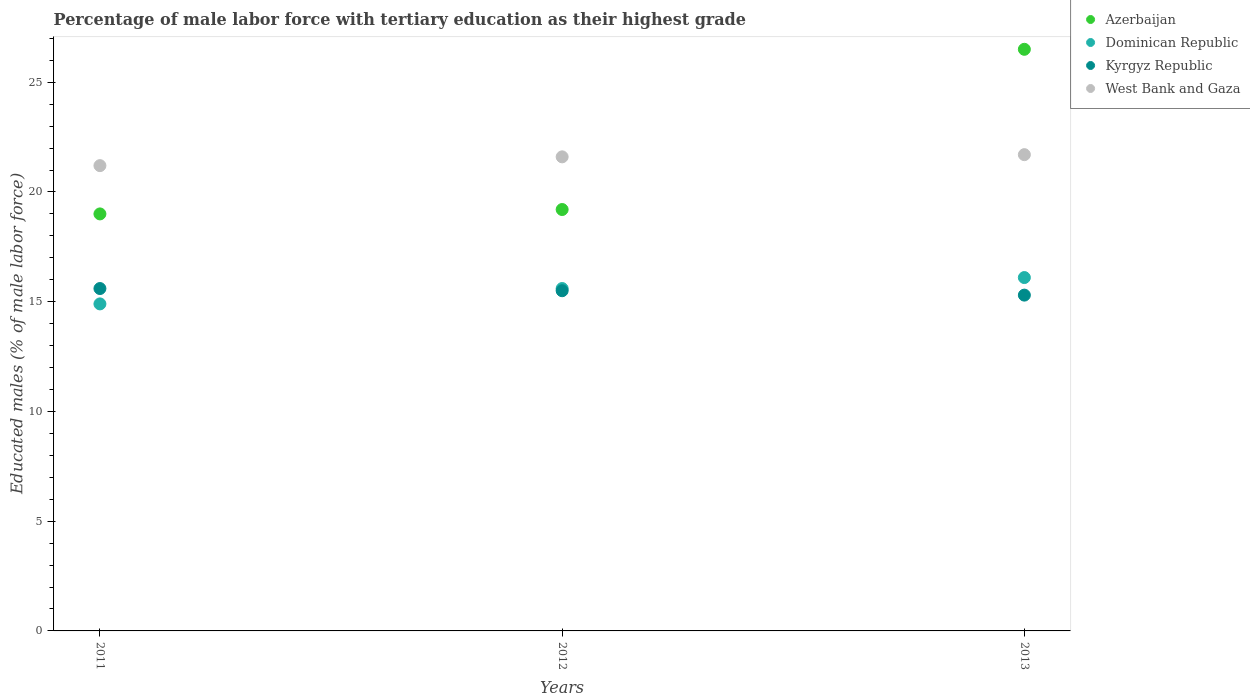What is the percentage of male labor force with tertiary education in West Bank and Gaza in 2011?
Offer a terse response. 21.2. Across all years, what is the maximum percentage of male labor force with tertiary education in Dominican Republic?
Ensure brevity in your answer.  16.1. Across all years, what is the minimum percentage of male labor force with tertiary education in Dominican Republic?
Give a very brief answer. 14.9. What is the total percentage of male labor force with tertiary education in Azerbaijan in the graph?
Keep it short and to the point. 64.7. What is the difference between the percentage of male labor force with tertiary education in Azerbaijan in 2012 and that in 2013?
Keep it short and to the point. -7.3. What is the difference between the percentage of male labor force with tertiary education in West Bank and Gaza in 2011 and the percentage of male labor force with tertiary education in Kyrgyz Republic in 2012?
Offer a terse response. 5.7. What is the average percentage of male labor force with tertiary education in Azerbaijan per year?
Give a very brief answer. 21.57. In the year 2011, what is the difference between the percentage of male labor force with tertiary education in Dominican Republic and percentage of male labor force with tertiary education in Kyrgyz Republic?
Provide a succinct answer. -0.7. In how many years, is the percentage of male labor force with tertiary education in Kyrgyz Republic greater than 2 %?
Your answer should be very brief. 3. What is the ratio of the percentage of male labor force with tertiary education in Dominican Republic in 2011 to that in 2013?
Ensure brevity in your answer.  0.93. What is the difference between the highest and the second highest percentage of male labor force with tertiary education in West Bank and Gaza?
Give a very brief answer. 0.1. What is the difference between the highest and the lowest percentage of male labor force with tertiary education in Kyrgyz Republic?
Keep it short and to the point. 0.3. In how many years, is the percentage of male labor force with tertiary education in Dominican Republic greater than the average percentage of male labor force with tertiary education in Dominican Republic taken over all years?
Keep it short and to the point. 2. Is the sum of the percentage of male labor force with tertiary education in Dominican Republic in 2011 and 2012 greater than the maximum percentage of male labor force with tertiary education in West Bank and Gaza across all years?
Give a very brief answer. Yes. Is it the case that in every year, the sum of the percentage of male labor force with tertiary education in Azerbaijan and percentage of male labor force with tertiary education in West Bank and Gaza  is greater than the sum of percentage of male labor force with tertiary education in Dominican Republic and percentage of male labor force with tertiary education in Kyrgyz Republic?
Provide a short and direct response. Yes. Does the percentage of male labor force with tertiary education in Dominican Republic monotonically increase over the years?
Provide a succinct answer. Yes. Is the percentage of male labor force with tertiary education in Dominican Republic strictly greater than the percentage of male labor force with tertiary education in Azerbaijan over the years?
Offer a terse response. No. Is the percentage of male labor force with tertiary education in Kyrgyz Republic strictly less than the percentage of male labor force with tertiary education in Dominican Republic over the years?
Provide a succinct answer. No. How many dotlines are there?
Give a very brief answer. 4. How many years are there in the graph?
Your response must be concise. 3. Does the graph contain any zero values?
Ensure brevity in your answer.  No. Does the graph contain grids?
Keep it short and to the point. No. Where does the legend appear in the graph?
Your answer should be compact. Top right. How many legend labels are there?
Give a very brief answer. 4. What is the title of the graph?
Your answer should be very brief. Percentage of male labor force with tertiary education as their highest grade. Does "Solomon Islands" appear as one of the legend labels in the graph?
Offer a terse response. No. What is the label or title of the Y-axis?
Your answer should be compact. Educated males (% of male labor force). What is the Educated males (% of male labor force) in Dominican Republic in 2011?
Your answer should be very brief. 14.9. What is the Educated males (% of male labor force) in Kyrgyz Republic in 2011?
Offer a very short reply. 15.6. What is the Educated males (% of male labor force) of West Bank and Gaza in 2011?
Give a very brief answer. 21.2. What is the Educated males (% of male labor force) in Azerbaijan in 2012?
Your answer should be very brief. 19.2. What is the Educated males (% of male labor force) of Dominican Republic in 2012?
Ensure brevity in your answer.  15.6. What is the Educated males (% of male labor force) of Kyrgyz Republic in 2012?
Ensure brevity in your answer.  15.5. What is the Educated males (% of male labor force) in West Bank and Gaza in 2012?
Keep it short and to the point. 21.6. What is the Educated males (% of male labor force) of Azerbaijan in 2013?
Keep it short and to the point. 26.5. What is the Educated males (% of male labor force) in Dominican Republic in 2013?
Offer a very short reply. 16.1. What is the Educated males (% of male labor force) in Kyrgyz Republic in 2013?
Offer a very short reply. 15.3. What is the Educated males (% of male labor force) in West Bank and Gaza in 2013?
Your response must be concise. 21.7. Across all years, what is the maximum Educated males (% of male labor force) of Azerbaijan?
Offer a terse response. 26.5. Across all years, what is the maximum Educated males (% of male labor force) of Dominican Republic?
Your answer should be very brief. 16.1. Across all years, what is the maximum Educated males (% of male labor force) in Kyrgyz Republic?
Ensure brevity in your answer.  15.6. Across all years, what is the maximum Educated males (% of male labor force) of West Bank and Gaza?
Your answer should be very brief. 21.7. Across all years, what is the minimum Educated males (% of male labor force) of Dominican Republic?
Give a very brief answer. 14.9. Across all years, what is the minimum Educated males (% of male labor force) in Kyrgyz Republic?
Provide a succinct answer. 15.3. Across all years, what is the minimum Educated males (% of male labor force) of West Bank and Gaza?
Offer a terse response. 21.2. What is the total Educated males (% of male labor force) of Azerbaijan in the graph?
Provide a short and direct response. 64.7. What is the total Educated males (% of male labor force) in Dominican Republic in the graph?
Offer a very short reply. 46.6. What is the total Educated males (% of male labor force) of Kyrgyz Republic in the graph?
Provide a short and direct response. 46.4. What is the total Educated males (% of male labor force) in West Bank and Gaza in the graph?
Ensure brevity in your answer.  64.5. What is the difference between the Educated males (% of male labor force) in Azerbaijan in 2011 and that in 2012?
Ensure brevity in your answer.  -0.2. What is the difference between the Educated males (% of male labor force) of Kyrgyz Republic in 2011 and that in 2012?
Your response must be concise. 0.1. What is the difference between the Educated males (% of male labor force) of West Bank and Gaza in 2011 and that in 2012?
Offer a very short reply. -0.4. What is the difference between the Educated males (% of male labor force) in Azerbaijan in 2011 and that in 2013?
Offer a terse response. -7.5. What is the difference between the Educated males (% of male labor force) of Kyrgyz Republic in 2011 and that in 2013?
Your answer should be very brief. 0.3. What is the difference between the Educated males (% of male labor force) in West Bank and Gaza in 2011 and that in 2013?
Make the answer very short. -0.5. What is the difference between the Educated males (% of male labor force) in Dominican Republic in 2012 and that in 2013?
Make the answer very short. -0.5. What is the difference between the Educated males (% of male labor force) in West Bank and Gaza in 2012 and that in 2013?
Your response must be concise. -0.1. What is the difference between the Educated males (% of male labor force) of Azerbaijan in 2011 and the Educated males (% of male labor force) of Dominican Republic in 2012?
Make the answer very short. 3.4. What is the difference between the Educated males (% of male labor force) of Dominican Republic in 2011 and the Educated males (% of male labor force) of Kyrgyz Republic in 2012?
Offer a terse response. -0.6. What is the difference between the Educated males (% of male labor force) of Dominican Republic in 2011 and the Educated males (% of male labor force) of West Bank and Gaza in 2012?
Provide a succinct answer. -6.7. What is the difference between the Educated males (% of male labor force) in Kyrgyz Republic in 2011 and the Educated males (% of male labor force) in West Bank and Gaza in 2012?
Offer a very short reply. -6. What is the difference between the Educated males (% of male labor force) in Azerbaijan in 2011 and the Educated males (% of male labor force) in Dominican Republic in 2013?
Your response must be concise. 2.9. What is the difference between the Educated males (% of male labor force) in Dominican Republic in 2011 and the Educated males (% of male labor force) in Kyrgyz Republic in 2013?
Make the answer very short. -0.4. What is the difference between the Educated males (% of male labor force) of Dominican Republic in 2011 and the Educated males (% of male labor force) of West Bank and Gaza in 2013?
Offer a terse response. -6.8. What is the difference between the Educated males (% of male labor force) in Kyrgyz Republic in 2011 and the Educated males (% of male labor force) in West Bank and Gaza in 2013?
Ensure brevity in your answer.  -6.1. What is the difference between the Educated males (% of male labor force) in Azerbaijan in 2012 and the Educated males (% of male labor force) in West Bank and Gaza in 2013?
Provide a succinct answer. -2.5. What is the difference between the Educated males (% of male labor force) of Dominican Republic in 2012 and the Educated males (% of male labor force) of Kyrgyz Republic in 2013?
Make the answer very short. 0.3. What is the difference between the Educated males (% of male labor force) in Dominican Republic in 2012 and the Educated males (% of male labor force) in West Bank and Gaza in 2013?
Provide a succinct answer. -6.1. What is the average Educated males (% of male labor force) in Azerbaijan per year?
Give a very brief answer. 21.57. What is the average Educated males (% of male labor force) in Dominican Republic per year?
Your answer should be compact. 15.53. What is the average Educated males (% of male labor force) of Kyrgyz Republic per year?
Provide a short and direct response. 15.47. In the year 2011, what is the difference between the Educated males (% of male labor force) of Azerbaijan and Educated males (% of male labor force) of Kyrgyz Republic?
Keep it short and to the point. 3.4. In the year 2012, what is the difference between the Educated males (% of male labor force) of Azerbaijan and Educated males (% of male labor force) of Kyrgyz Republic?
Provide a succinct answer. 3.7. In the year 2012, what is the difference between the Educated males (% of male labor force) in Azerbaijan and Educated males (% of male labor force) in West Bank and Gaza?
Provide a succinct answer. -2.4. In the year 2012, what is the difference between the Educated males (% of male labor force) of Dominican Republic and Educated males (% of male labor force) of Kyrgyz Republic?
Offer a very short reply. 0.1. In the year 2012, what is the difference between the Educated males (% of male labor force) of Dominican Republic and Educated males (% of male labor force) of West Bank and Gaza?
Your answer should be compact. -6. In the year 2013, what is the difference between the Educated males (% of male labor force) of Azerbaijan and Educated males (% of male labor force) of Dominican Republic?
Offer a very short reply. 10.4. In the year 2013, what is the difference between the Educated males (% of male labor force) of Azerbaijan and Educated males (% of male labor force) of Kyrgyz Republic?
Keep it short and to the point. 11.2. In the year 2013, what is the difference between the Educated males (% of male labor force) in Kyrgyz Republic and Educated males (% of male labor force) in West Bank and Gaza?
Offer a terse response. -6.4. What is the ratio of the Educated males (% of male labor force) of Azerbaijan in 2011 to that in 2012?
Provide a succinct answer. 0.99. What is the ratio of the Educated males (% of male labor force) of Dominican Republic in 2011 to that in 2012?
Ensure brevity in your answer.  0.96. What is the ratio of the Educated males (% of male labor force) of West Bank and Gaza in 2011 to that in 2012?
Ensure brevity in your answer.  0.98. What is the ratio of the Educated males (% of male labor force) in Azerbaijan in 2011 to that in 2013?
Make the answer very short. 0.72. What is the ratio of the Educated males (% of male labor force) of Dominican Republic in 2011 to that in 2013?
Offer a very short reply. 0.93. What is the ratio of the Educated males (% of male labor force) of Kyrgyz Republic in 2011 to that in 2013?
Keep it short and to the point. 1.02. What is the ratio of the Educated males (% of male labor force) of Azerbaijan in 2012 to that in 2013?
Ensure brevity in your answer.  0.72. What is the ratio of the Educated males (% of male labor force) in Dominican Republic in 2012 to that in 2013?
Keep it short and to the point. 0.97. What is the ratio of the Educated males (% of male labor force) in Kyrgyz Republic in 2012 to that in 2013?
Offer a very short reply. 1.01. What is the ratio of the Educated males (% of male labor force) of West Bank and Gaza in 2012 to that in 2013?
Your answer should be compact. 1. What is the difference between the highest and the second highest Educated males (% of male labor force) in West Bank and Gaza?
Your answer should be very brief. 0.1. What is the difference between the highest and the lowest Educated males (% of male labor force) in Azerbaijan?
Ensure brevity in your answer.  7.5. What is the difference between the highest and the lowest Educated males (% of male labor force) in Dominican Republic?
Offer a very short reply. 1.2. What is the difference between the highest and the lowest Educated males (% of male labor force) of West Bank and Gaza?
Your answer should be compact. 0.5. 